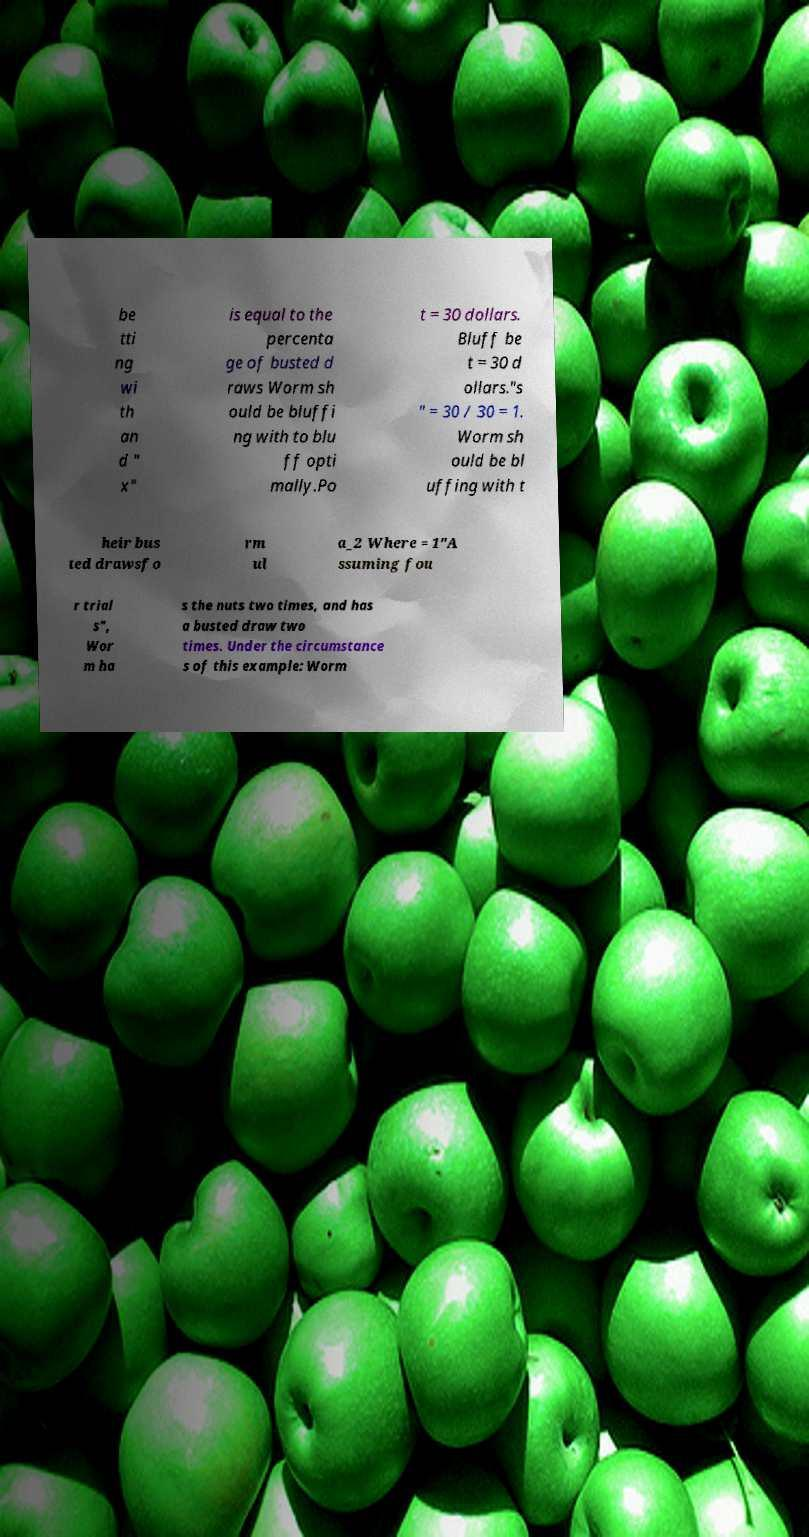There's text embedded in this image that I need extracted. Can you transcribe it verbatim? be tti ng wi th an d " x" is equal to the percenta ge of busted d raws Worm sh ould be bluffi ng with to blu ff opti mally.Po t = 30 dollars. Bluff be t = 30 d ollars."s " = 30 / 30 = 1. Worm sh ould be bl uffing with t heir bus ted drawsfo rm ul a_2 Where = 1"A ssuming fou r trial s", Wor m ha s the nuts two times, and has a busted draw two times. Under the circumstance s of this example: Worm 